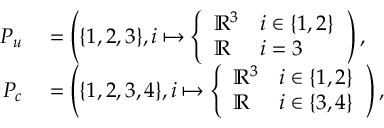Convert formula to latex. <formula><loc_0><loc_0><loc_500><loc_500>\begin{array} { r l } { P _ { u } } & = \left ( \{ 1 , 2 , 3 \} , i \mapsto \left \{ \begin{array} { l l } { \mathbb { R } ^ { 3 } } & { i \in \{ 1 , 2 \} } \\ { \mathbb { R } } & { i = 3 } \end{array} \right ) , } \\ { P _ { c } } & = \left ( \{ 1 , 2 , 3 , 4 \} , i \mapsto \left \{ \begin{array} { l l } { \mathbb { R } ^ { 3 } } & { i \in \{ 1 , 2 \} } \\ { \mathbb { R } } & { i \in \{ 3 , 4 \} } \end{array} \right ) , } \end{array}</formula> 